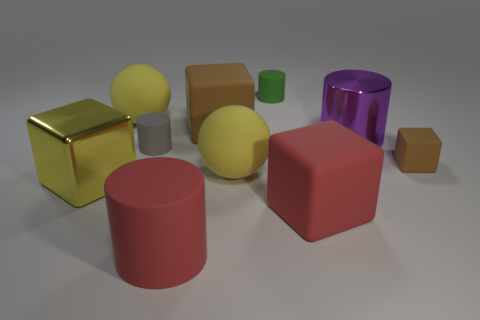What different shapes can be seen in the image? The image features a range of geometric shapes including cubes, spheres, cylinders, and a single hexagonal prism. 